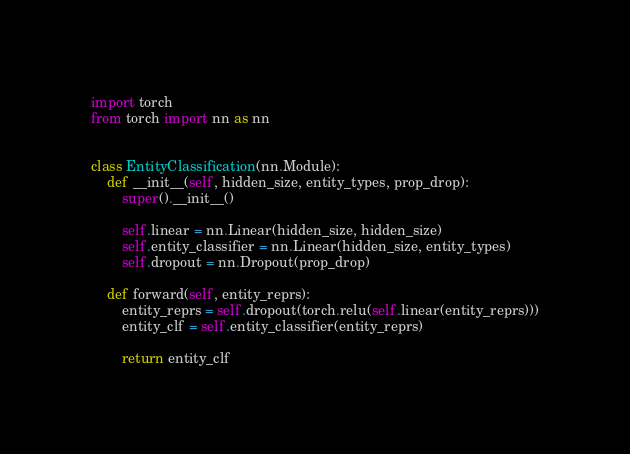<code> <loc_0><loc_0><loc_500><loc_500><_Python_>import torch
from torch import nn as nn


class EntityClassification(nn.Module):
    def __init__(self, hidden_size, entity_types, prop_drop):
        super().__init__()

        self.linear = nn.Linear(hidden_size, hidden_size)
        self.entity_classifier = nn.Linear(hidden_size, entity_types)
        self.dropout = nn.Dropout(prop_drop)

    def forward(self, entity_reprs):
        entity_reprs = self.dropout(torch.relu(self.linear(entity_reprs)))
        entity_clf = self.entity_classifier(entity_reprs)

        return entity_clf
</code> 